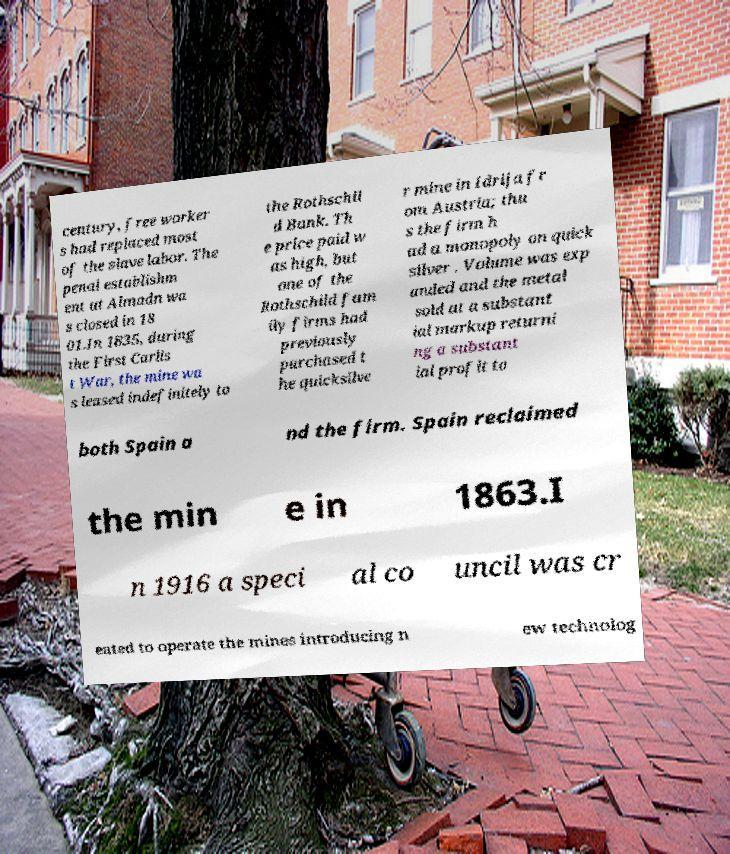For documentation purposes, I need the text within this image transcribed. Could you provide that? century, free worker s had replaced most of the slave labor. The penal establishm ent at Almadn wa s closed in 18 01.In 1835, during the First Carlis t War, the mine wa s leased indefinitely to the Rothschil d Bank. Th e price paid w as high, but one of the Rothschild fam ily firms had previously purchased t he quicksilve r mine in Idrija fr om Austria; thu s the firm h ad a monopoly on quick silver . Volume was exp anded and the metal sold at a substant ial markup returni ng a substant ial profit to both Spain a nd the firm. Spain reclaimed the min e in 1863.I n 1916 a speci al co uncil was cr eated to operate the mines introducing n ew technolog 